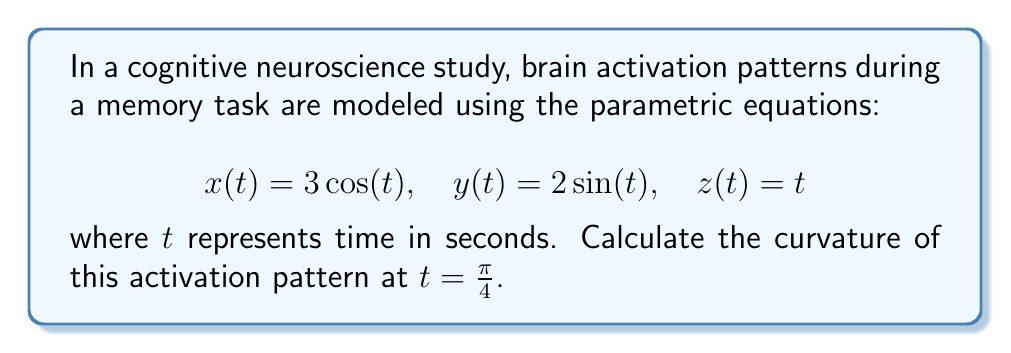Show me your answer to this math problem. To find the curvature of a 3D curve given by parametric equations, we'll use the formula:

$$\kappa = \frac{\sqrt{|\mathbf{r}'(t) \times \mathbf{r}''(t)|^2}}{|\mathbf{r}'(t)|^3}$$

where $\mathbf{r}(t) = (x(t), y(t), z(t))$.

Step 1: Calculate $\mathbf{r}'(t)$
$$\mathbf{r}'(t) = (-3\sin(t), 2\cos(t), 1)$$

Step 2: Calculate $\mathbf{r}''(t)$
$$\mathbf{r}''(t) = (-3\cos(t), -2\sin(t), 0)$$

Step 3: Calculate $\mathbf{r}'(t) \times \mathbf{r}''(t)$
$$\mathbf{r}'(t) \times \mathbf{r}''(t) = \begin{vmatrix} 
\mathbf{i} & \mathbf{j} & \mathbf{k} \\
-3\sin(t) & 2\cos(t) & 1 \\
-3\cos(t) & -2\sin(t) & 0
\end{vmatrix}$$

$$= (2\cos(t) \cdot 0 - 1 \cdot (-2\sin(t)))\mathbf{i} + (1 \cdot (-3\cos(t)) - (-3\sin(t) \cdot 0))\mathbf{j} + (-3\sin(t) \cdot (-2\sin(t)) - 2\cos(t) \cdot (-3\cos(t)))\mathbf{k}$$

$$= 2\sin(t)\mathbf{i} - 3\cos(t)\mathbf{j} + (6\sin^2(t) + 6\cos^2(t))\mathbf{k}$$

$$= 2\sin(t)\mathbf{i} - 3\cos(t)\mathbf{j} + 6\mathbf{k}$$

Step 4: Calculate $|\mathbf{r}'(t) \times \mathbf{r}''(t)|^2$
$$|\mathbf{r}'(t) \times \mathbf{r}''(t)|^2 = 4\sin^2(t) + 9\cos^2(t) + 36$$

Step 5: Calculate $|\mathbf{r}'(t)|^3$
$$|\mathbf{r}'(t)|^3 = (9\sin^2(t) + 4\cos^2(t) + 1)^{3/2}$$

Step 6: Substitute $t = \frac{\pi}{4}$ into the curvature formula
$$\kappa = \frac{\sqrt{4\sin^2(\frac{\pi}{4}) + 9\cos^2(\frac{\pi}{4}) + 36}}{(9\sin^2(\frac{\pi}{4}) + 4\cos^2(\frac{\pi}{4}) + 1)^{3/2}}$$

$$= \frac{\sqrt{4(\frac{1}{\sqrt{2}})^2 + 9(\frac{1}{\sqrt{2}})^2 + 36}}{(9(\frac{1}{\sqrt{2}})^2 + 4(\frac{1}{\sqrt{2}})^2 + 1)^{3/2}}$$

$$= \frac{\sqrt{2 + 4.5 + 36}}{(4.5 + 2 + 1)^{3/2}} = \frac{\sqrt{42.5}}{7.5^{3/2}} \approx 0.3651$$
Answer: $\frac{\sqrt{42.5}}{7.5^{3/2}} \approx 0.3651$ 